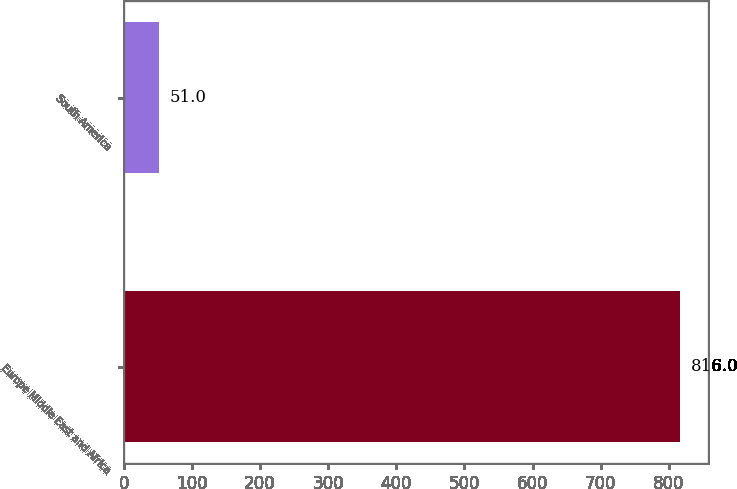Convert chart to OTSL. <chart><loc_0><loc_0><loc_500><loc_500><bar_chart><fcel>Europe Middle East and Africa<fcel>South America<nl><fcel>816<fcel>51<nl></chart> 